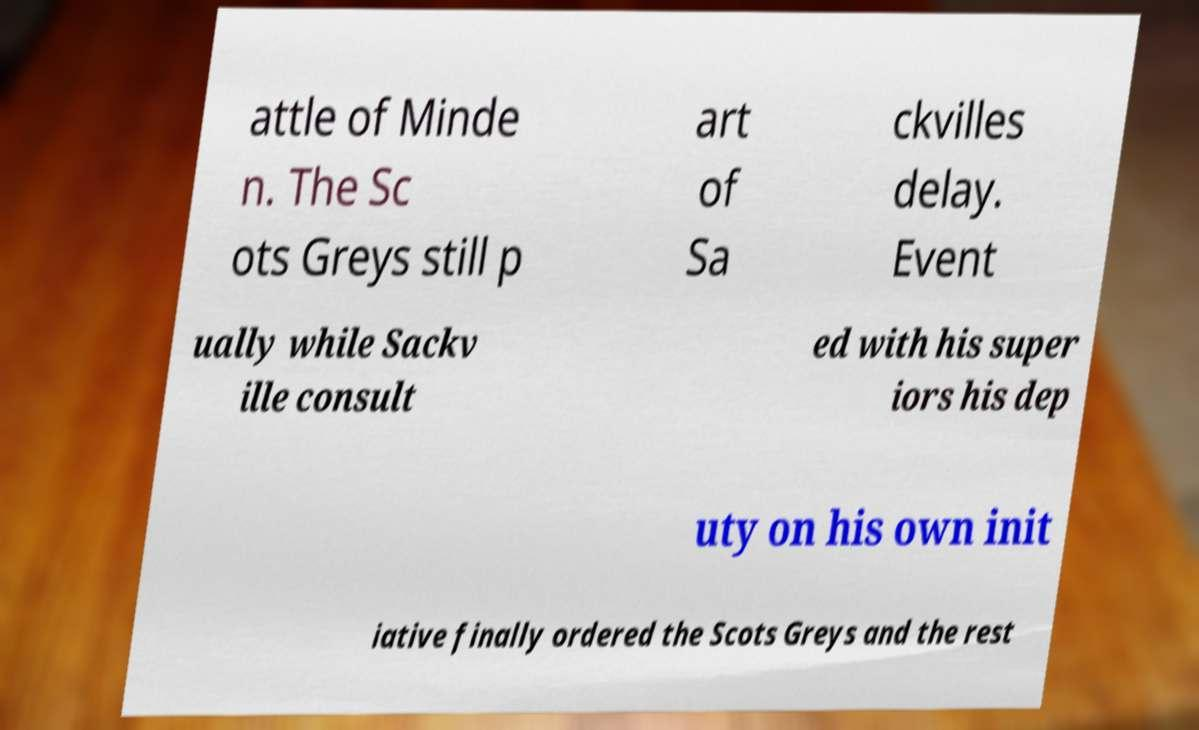Can you accurately transcribe the text from the provided image for me? attle of Minde n. The Sc ots Greys still p art of Sa ckvilles delay. Event ually while Sackv ille consult ed with his super iors his dep uty on his own init iative finally ordered the Scots Greys and the rest 